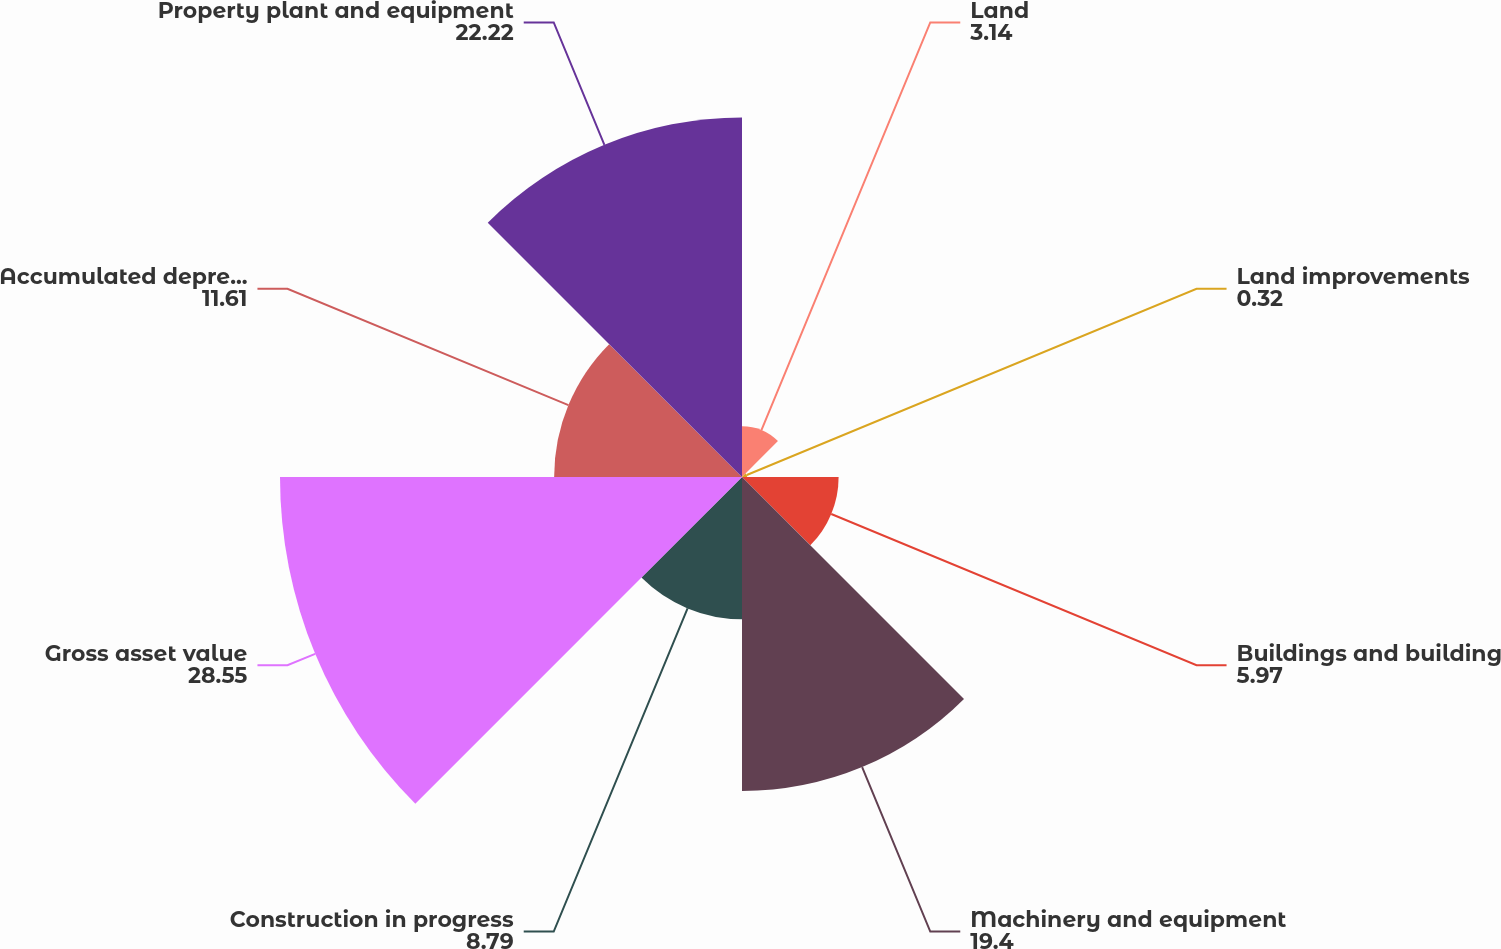Convert chart to OTSL. <chart><loc_0><loc_0><loc_500><loc_500><pie_chart><fcel>Land<fcel>Land improvements<fcel>Buildings and building<fcel>Machinery and equipment<fcel>Construction in progress<fcel>Gross asset value<fcel>Accumulated depreciation<fcel>Property plant and equipment<nl><fcel>3.14%<fcel>0.32%<fcel>5.97%<fcel>19.4%<fcel>8.79%<fcel>28.55%<fcel>11.61%<fcel>22.22%<nl></chart> 